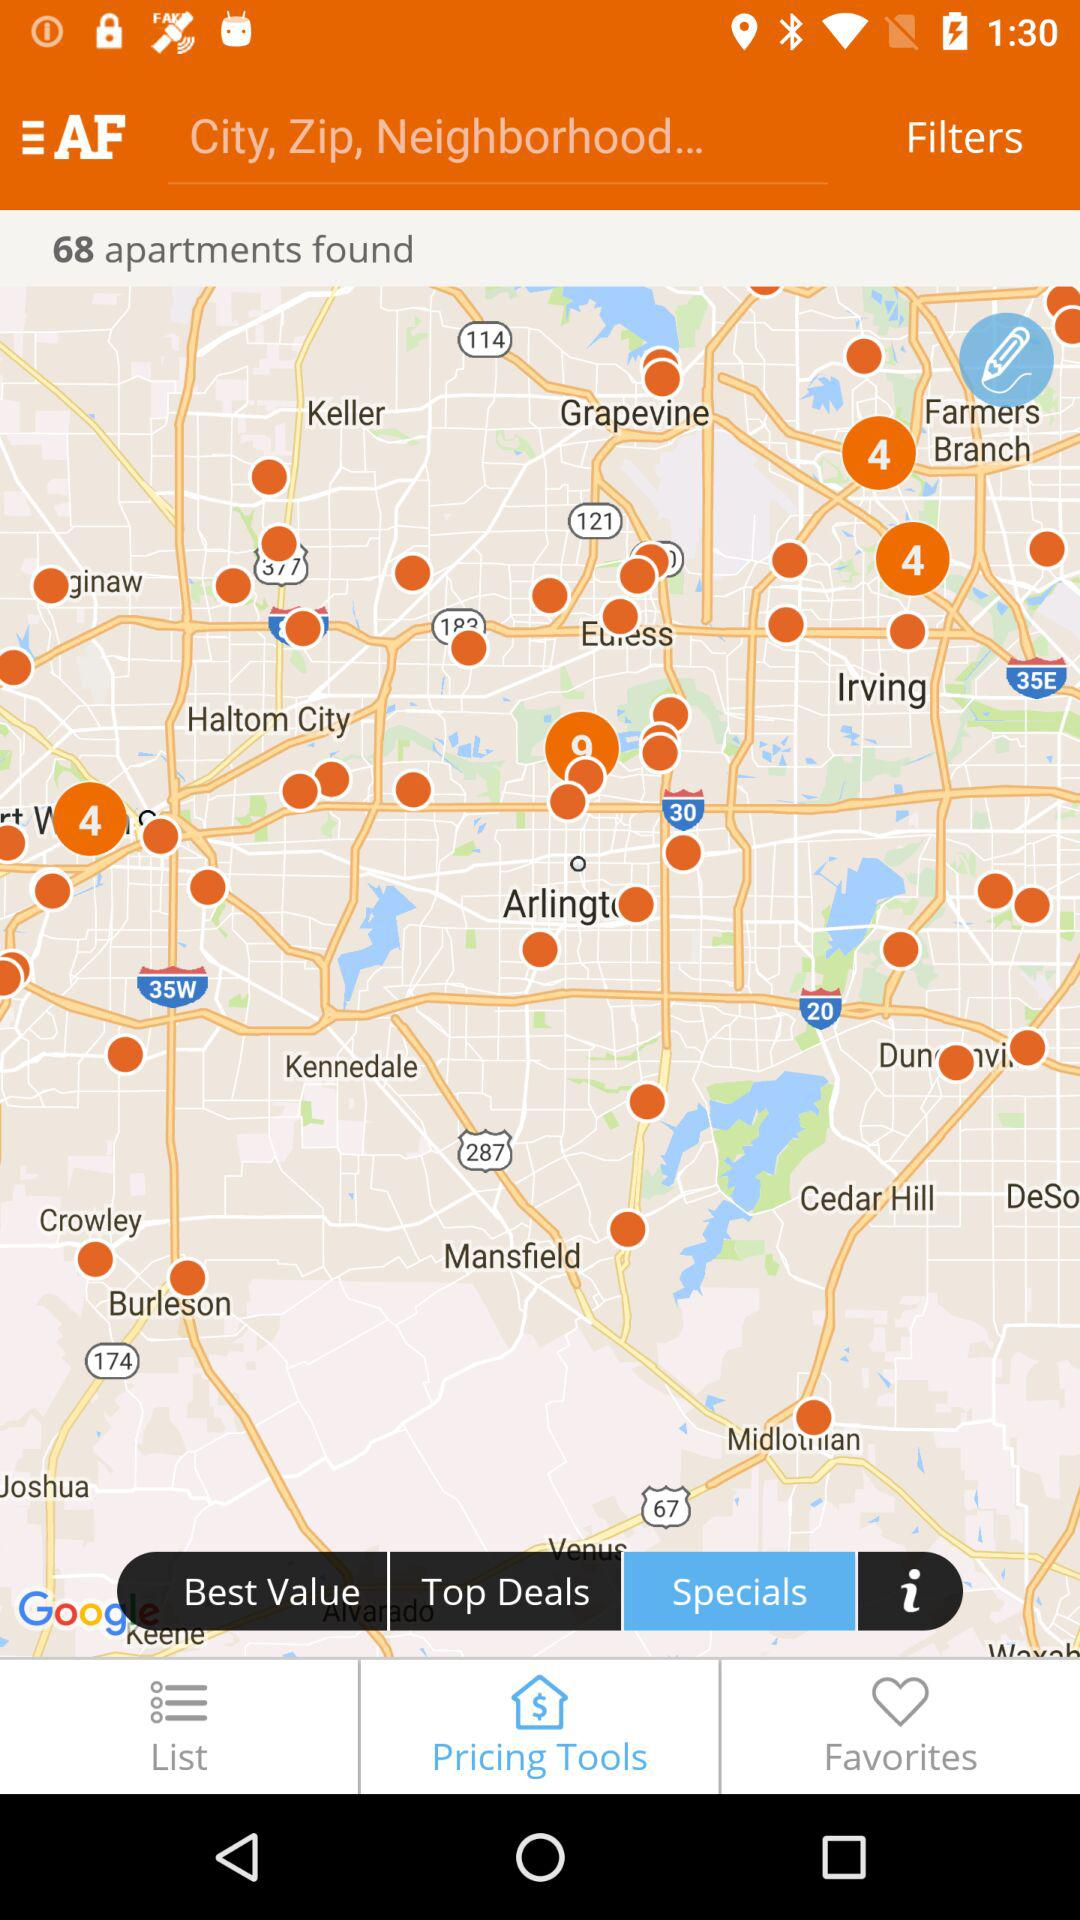How many apartments are there on the map?
Answer the question using a single word or phrase. 68 